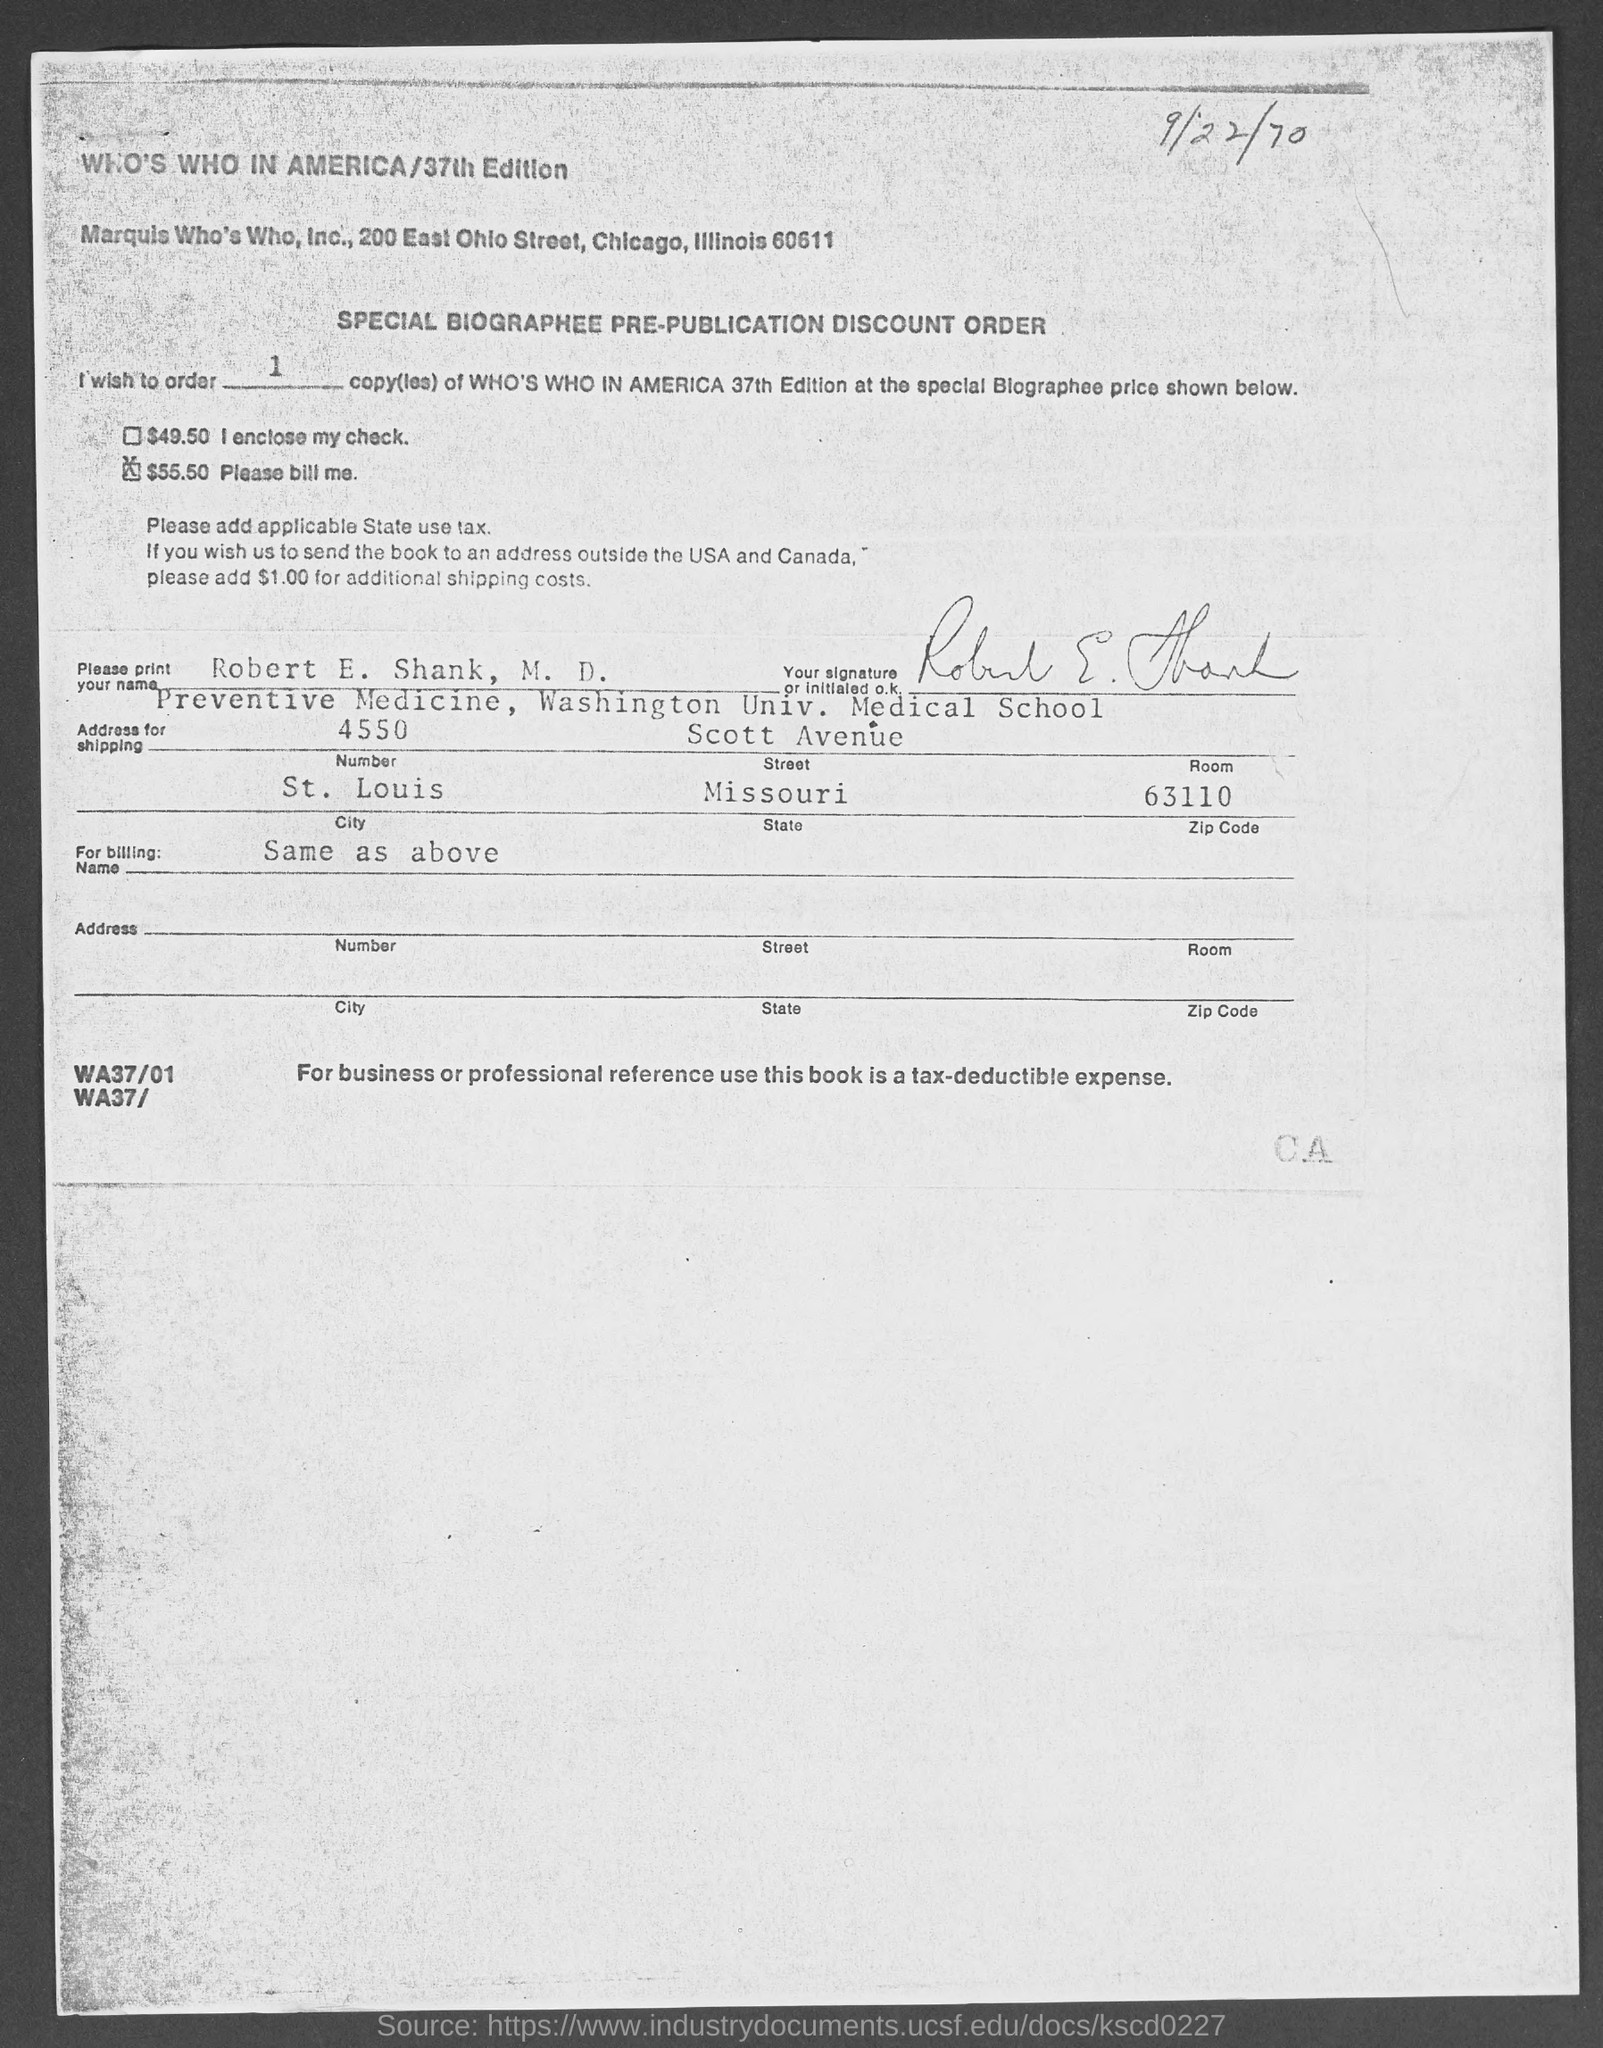Identify some key points in this picture. Washington University Medical School is located in the state of Missouri. Marquis Who's Who, Inc., is located in the state of Illinois. 